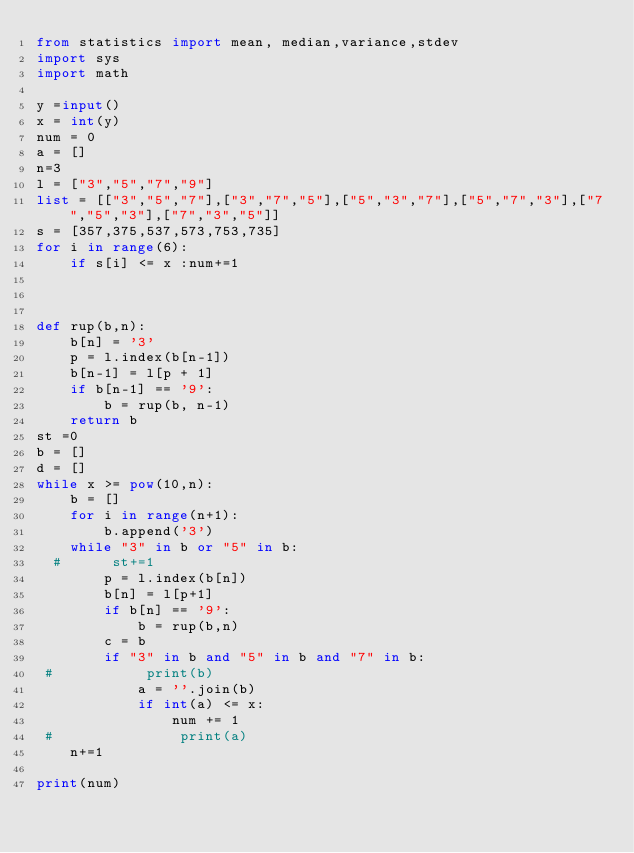<code> <loc_0><loc_0><loc_500><loc_500><_Python_>from statistics import mean, median,variance,stdev
import sys
import math

y =input()
x = int(y)
num = 0
a = []
n=3
l = ["3","5","7","9"]
list = [["3","5","7"],["3","7","5"],["5","3","7"],["5","7","3"],["7","5","3"],["7","3","5"]]
s = [357,375,537,573,753,735]
for i in range(6):
    if s[i] <= x :num+=1



def rup(b,n):
    b[n] = '3'
    p = l.index(b[n-1])
    b[n-1] = l[p + 1]
    if b[n-1] == '9':
        b = rup(b, n-1)
    return b
st =0
b = []
d = []
while x >= pow(10,n):
    b = []
    for i in range(n+1):
        b.append('3')
    while "3" in b or "5" in b:
  #      st+=1
        p = l.index(b[n])
        b[n] = l[p+1]
        if b[n] == '9':
            b = rup(b,n)
        c = b
        if "3" in b and "5" in b and "7" in b:
 #           print(b)
            a = ''.join(b)
            if int(a) <= x:
                num += 1
 #               print(a)
    n+=1

print(num)
</code> 